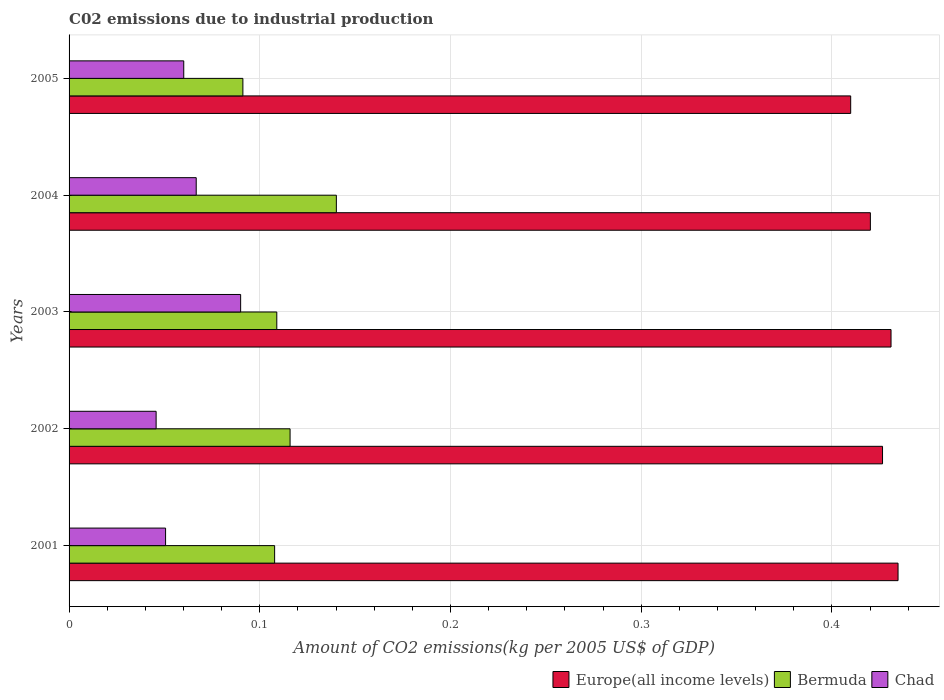How many groups of bars are there?
Your answer should be compact. 5. Are the number of bars per tick equal to the number of legend labels?
Your answer should be compact. Yes. In how many cases, is the number of bars for a given year not equal to the number of legend labels?
Offer a very short reply. 0. What is the amount of CO2 emitted due to industrial production in Chad in 2001?
Your response must be concise. 0.05. Across all years, what is the maximum amount of CO2 emitted due to industrial production in Bermuda?
Your answer should be compact. 0.14. Across all years, what is the minimum amount of CO2 emitted due to industrial production in Chad?
Your answer should be compact. 0.05. In which year was the amount of CO2 emitted due to industrial production in Bermuda maximum?
Keep it short and to the point. 2004. What is the total amount of CO2 emitted due to industrial production in Bermuda in the graph?
Provide a succinct answer. 0.56. What is the difference between the amount of CO2 emitted due to industrial production in Chad in 2001 and that in 2002?
Your answer should be compact. 0. What is the difference between the amount of CO2 emitted due to industrial production in Europe(all income levels) in 2001 and the amount of CO2 emitted due to industrial production in Chad in 2003?
Your answer should be very brief. 0.34. What is the average amount of CO2 emitted due to industrial production in Bermuda per year?
Provide a succinct answer. 0.11. In the year 2003, what is the difference between the amount of CO2 emitted due to industrial production in Chad and amount of CO2 emitted due to industrial production in Bermuda?
Provide a succinct answer. -0.02. What is the ratio of the amount of CO2 emitted due to industrial production in Chad in 2001 to that in 2003?
Offer a terse response. 0.56. Is the amount of CO2 emitted due to industrial production in Chad in 2004 less than that in 2005?
Offer a very short reply. No. Is the difference between the amount of CO2 emitted due to industrial production in Chad in 2004 and 2005 greater than the difference between the amount of CO2 emitted due to industrial production in Bermuda in 2004 and 2005?
Offer a very short reply. No. What is the difference between the highest and the second highest amount of CO2 emitted due to industrial production in Europe(all income levels)?
Keep it short and to the point. 0. What is the difference between the highest and the lowest amount of CO2 emitted due to industrial production in Bermuda?
Offer a terse response. 0.05. In how many years, is the amount of CO2 emitted due to industrial production in Europe(all income levels) greater than the average amount of CO2 emitted due to industrial production in Europe(all income levels) taken over all years?
Your answer should be very brief. 3. What does the 3rd bar from the top in 2003 represents?
Your answer should be compact. Europe(all income levels). What does the 2nd bar from the bottom in 2003 represents?
Offer a terse response. Bermuda. Are all the bars in the graph horizontal?
Your response must be concise. Yes. How many years are there in the graph?
Your answer should be compact. 5. What is the difference between two consecutive major ticks on the X-axis?
Keep it short and to the point. 0.1. Does the graph contain grids?
Provide a succinct answer. Yes. How many legend labels are there?
Your response must be concise. 3. How are the legend labels stacked?
Ensure brevity in your answer.  Horizontal. What is the title of the graph?
Offer a terse response. C02 emissions due to industrial production. Does "Seychelles" appear as one of the legend labels in the graph?
Provide a short and direct response. No. What is the label or title of the X-axis?
Provide a succinct answer. Amount of CO2 emissions(kg per 2005 US$ of GDP). What is the label or title of the Y-axis?
Keep it short and to the point. Years. What is the Amount of CO2 emissions(kg per 2005 US$ of GDP) in Europe(all income levels) in 2001?
Your answer should be compact. 0.43. What is the Amount of CO2 emissions(kg per 2005 US$ of GDP) in Bermuda in 2001?
Your response must be concise. 0.11. What is the Amount of CO2 emissions(kg per 2005 US$ of GDP) of Chad in 2001?
Your answer should be very brief. 0.05. What is the Amount of CO2 emissions(kg per 2005 US$ of GDP) of Europe(all income levels) in 2002?
Offer a very short reply. 0.43. What is the Amount of CO2 emissions(kg per 2005 US$ of GDP) in Bermuda in 2002?
Provide a short and direct response. 0.12. What is the Amount of CO2 emissions(kg per 2005 US$ of GDP) of Chad in 2002?
Your answer should be compact. 0.05. What is the Amount of CO2 emissions(kg per 2005 US$ of GDP) of Europe(all income levels) in 2003?
Ensure brevity in your answer.  0.43. What is the Amount of CO2 emissions(kg per 2005 US$ of GDP) of Bermuda in 2003?
Provide a short and direct response. 0.11. What is the Amount of CO2 emissions(kg per 2005 US$ of GDP) of Chad in 2003?
Offer a terse response. 0.09. What is the Amount of CO2 emissions(kg per 2005 US$ of GDP) of Europe(all income levels) in 2004?
Give a very brief answer. 0.42. What is the Amount of CO2 emissions(kg per 2005 US$ of GDP) in Bermuda in 2004?
Your response must be concise. 0.14. What is the Amount of CO2 emissions(kg per 2005 US$ of GDP) of Chad in 2004?
Give a very brief answer. 0.07. What is the Amount of CO2 emissions(kg per 2005 US$ of GDP) in Europe(all income levels) in 2005?
Provide a short and direct response. 0.41. What is the Amount of CO2 emissions(kg per 2005 US$ of GDP) in Bermuda in 2005?
Your answer should be compact. 0.09. What is the Amount of CO2 emissions(kg per 2005 US$ of GDP) in Chad in 2005?
Provide a short and direct response. 0.06. Across all years, what is the maximum Amount of CO2 emissions(kg per 2005 US$ of GDP) of Europe(all income levels)?
Offer a very short reply. 0.43. Across all years, what is the maximum Amount of CO2 emissions(kg per 2005 US$ of GDP) of Bermuda?
Your response must be concise. 0.14. Across all years, what is the maximum Amount of CO2 emissions(kg per 2005 US$ of GDP) of Chad?
Keep it short and to the point. 0.09. Across all years, what is the minimum Amount of CO2 emissions(kg per 2005 US$ of GDP) of Europe(all income levels)?
Provide a succinct answer. 0.41. Across all years, what is the minimum Amount of CO2 emissions(kg per 2005 US$ of GDP) of Bermuda?
Give a very brief answer. 0.09. Across all years, what is the minimum Amount of CO2 emissions(kg per 2005 US$ of GDP) of Chad?
Ensure brevity in your answer.  0.05. What is the total Amount of CO2 emissions(kg per 2005 US$ of GDP) in Europe(all income levels) in the graph?
Provide a succinct answer. 2.12. What is the total Amount of CO2 emissions(kg per 2005 US$ of GDP) in Bermuda in the graph?
Ensure brevity in your answer.  0.56. What is the total Amount of CO2 emissions(kg per 2005 US$ of GDP) of Chad in the graph?
Give a very brief answer. 0.31. What is the difference between the Amount of CO2 emissions(kg per 2005 US$ of GDP) of Europe(all income levels) in 2001 and that in 2002?
Provide a succinct answer. 0.01. What is the difference between the Amount of CO2 emissions(kg per 2005 US$ of GDP) in Bermuda in 2001 and that in 2002?
Offer a very short reply. -0.01. What is the difference between the Amount of CO2 emissions(kg per 2005 US$ of GDP) in Chad in 2001 and that in 2002?
Your answer should be very brief. 0.01. What is the difference between the Amount of CO2 emissions(kg per 2005 US$ of GDP) in Europe(all income levels) in 2001 and that in 2003?
Give a very brief answer. 0. What is the difference between the Amount of CO2 emissions(kg per 2005 US$ of GDP) in Bermuda in 2001 and that in 2003?
Give a very brief answer. -0. What is the difference between the Amount of CO2 emissions(kg per 2005 US$ of GDP) of Chad in 2001 and that in 2003?
Offer a terse response. -0.04. What is the difference between the Amount of CO2 emissions(kg per 2005 US$ of GDP) of Europe(all income levels) in 2001 and that in 2004?
Offer a terse response. 0.01. What is the difference between the Amount of CO2 emissions(kg per 2005 US$ of GDP) in Bermuda in 2001 and that in 2004?
Your answer should be very brief. -0.03. What is the difference between the Amount of CO2 emissions(kg per 2005 US$ of GDP) of Chad in 2001 and that in 2004?
Your answer should be compact. -0.02. What is the difference between the Amount of CO2 emissions(kg per 2005 US$ of GDP) in Europe(all income levels) in 2001 and that in 2005?
Offer a terse response. 0.02. What is the difference between the Amount of CO2 emissions(kg per 2005 US$ of GDP) of Bermuda in 2001 and that in 2005?
Your answer should be compact. 0.02. What is the difference between the Amount of CO2 emissions(kg per 2005 US$ of GDP) of Chad in 2001 and that in 2005?
Your answer should be very brief. -0.01. What is the difference between the Amount of CO2 emissions(kg per 2005 US$ of GDP) in Europe(all income levels) in 2002 and that in 2003?
Keep it short and to the point. -0. What is the difference between the Amount of CO2 emissions(kg per 2005 US$ of GDP) of Bermuda in 2002 and that in 2003?
Provide a succinct answer. 0.01. What is the difference between the Amount of CO2 emissions(kg per 2005 US$ of GDP) of Chad in 2002 and that in 2003?
Your answer should be very brief. -0.04. What is the difference between the Amount of CO2 emissions(kg per 2005 US$ of GDP) of Europe(all income levels) in 2002 and that in 2004?
Offer a very short reply. 0.01. What is the difference between the Amount of CO2 emissions(kg per 2005 US$ of GDP) in Bermuda in 2002 and that in 2004?
Provide a short and direct response. -0.02. What is the difference between the Amount of CO2 emissions(kg per 2005 US$ of GDP) in Chad in 2002 and that in 2004?
Offer a terse response. -0.02. What is the difference between the Amount of CO2 emissions(kg per 2005 US$ of GDP) of Europe(all income levels) in 2002 and that in 2005?
Your answer should be compact. 0.02. What is the difference between the Amount of CO2 emissions(kg per 2005 US$ of GDP) of Bermuda in 2002 and that in 2005?
Keep it short and to the point. 0.02. What is the difference between the Amount of CO2 emissions(kg per 2005 US$ of GDP) in Chad in 2002 and that in 2005?
Offer a very short reply. -0.01. What is the difference between the Amount of CO2 emissions(kg per 2005 US$ of GDP) of Europe(all income levels) in 2003 and that in 2004?
Make the answer very short. 0.01. What is the difference between the Amount of CO2 emissions(kg per 2005 US$ of GDP) of Bermuda in 2003 and that in 2004?
Ensure brevity in your answer.  -0.03. What is the difference between the Amount of CO2 emissions(kg per 2005 US$ of GDP) of Chad in 2003 and that in 2004?
Keep it short and to the point. 0.02. What is the difference between the Amount of CO2 emissions(kg per 2005 US$ of GDP) of Europe(all income levels) in 2003 and that in 2005?
Make the answer very short. 0.02. What is the difference between the Amount of CO2 emissions(kg per 2005 US$ of GDP) of Bermuda in 2003 and that in 2005?
Your answer should be compact. 0.02. What is the difference between the Amount of CO2 emissions(kg per 2005 US$ of GDP) of Chad in 2003 and that in 2005?
Offer a terse response. 0.03. What is the difference between the Amount of CO2 emissions(kg per 2005 US$ of GDP) of Europe(all income levels) in 2004 and that in 2005?
Offer a terse response. 0.01. What is the difference between the Amount of CO2 emissions(kg per 2005 US$ of GDP) of Bermuda in 2004 and that in 2005?
Keep it short and to the point. 0.05. What is the difference between the Amount of CO2 emissions(kg per 2005 US$ of GDP) of Chad in 2004 and that in 2005?
Provide a short and direct response. 0.01. What is the difference between the Amount of CO2 emissions(kg per 2005 US$ of GDP) of Europe(all income levels) in 2001 and the Amount of CO2 emissions(kg per 2005 US$ of GDP) of Bermuda in 2002?
Your answer should be very brief. 0.32. What is the difference between the Amount of CO2 emissions(kg per 2005 US$ of GDP) in Europe(all income levels) in 2001 and the Amount of CO2 emissions(kg per 2005 US$ of GDP) in Chad in 2002?
Keep it short and to the point. 0.39. What is the difference between the Amount of CO2 emissions(kg per 2005 US$ of GDP) of Bermuda in 2001 and the Amount of CO2 emissions(kg per 2005 US$ of GDP) of Chad in 2002?
Give a very brief answer. 0.06. What is the difference between the Amount of CO2 emissions(kg per 2005 US$ of GDP) in Europe(all income levels) in 2001 and the Amount of CO2 emissions(kg per 2005 US$ of GDP) in Bermuda in 2003?
Keep it short and to the point. 0.33. What is the difference between the Amount of CO2 emissions(kg per 2005 US$ of GDP) of Europe(all income levels) in 2001 and the Amount of CO2 emissions(kg per 2005 US$ of GDP) of Chad in 2003?
Keep it short and to the point. 0.34. What is the difference between the Amount of CO2 emissions(kg per 2005 US$ of GDP) in Bermuda in 2001 and the Amount of CO2 emissions(kg per 2005 US$ of GDP) in Chad in 2003?
Provide a short and direct response. 0.02. What is the difference between the Amount of CO2 emissions(kg per 2005 US$ of GDP) in Europe(all income levels) in 2001 and the Amount of CO2 emissions(kg per 2005 US$ of GDP) in Bermuda in 2004?
Offer a terse response. 0.29. What is the difference between the Amount of CO2 emissions(kg per 2005 US$ of GDP) of Europe(all income levels) in 2001 and the Amount of CO2 emissions(kg per 2005 US$ of GDP) of Chad in 2004?
Provide a succinct answer. 0.37. What is the difference between the Amount of CO2 emissions(kg per 2005 US$ of GDP) of Bermuda in 2001 and the Amount of CO2 emissions(kg per 2005 US$ of GDP) of Chad in 2004?
Offer a very short reply. 0.04. What is the difference between the Amount of CO2 emissions(kg per 2005 US$ of GDP) in Europe(all income levels) in 2001 and the Amount of CO2 emissions(kg per 2005 US$ of GDP) in Bermuda in 2005?
Give a very brief answer. 0.34. What is the difference between the Amount of CO2 emissions(kg per 2005 US$ of GDP) in Europe(all income levels) in 2001 and the Amount of CO2 emissions(kg per 2005 US$ of GDP) in Chad in 2005?
Your answer should be compact. 0.37. What is the difference between the Amount of CO2 emissions(kg per 2005 US$ of GDP) of Bermuda in 2001 and the Amount of CO2 emissions(kg per 2005 US$ of GDP) of Chad in 2005?
Your answer should be compact. 0.05. What is the difference between the Amount of CO2 emissions(kg per 2005 US$ of GDP) in Europe(all income levels) in 2002 and the Amount of CO2 emissions(kg per 2005 US$ of GDP) in Bermuda in 2003?
Make the answer very short. 0.32. What is the difference between the Amount of CO2 emissions(kg per 2005 US$ of GDP) in Europe(all income levels) in 2002 and the Amount of CO2 emissions(kg per 2005 US$ of GDP) in Chad in 2003?
Provide a succinct answer. 0.34. What is the difference between the Amount of CO2 emissions(kg per 2005 US$ of GDP) in Bermuda in 2002 and the Amount of CO2 emissions(kg per 2005 US$ of GDP) in Chad in 2003?
Ensure brevity in your answer.  0.03. What is the difference between the Amount of CO2 emissions(kg per 2005 US$ of GDP) of Europe(all income levels) in 2002 and the Amount of CO2 emissions(kg per 2005 US$ of GDP) of Bermuda in 2004?
Ensure brevity in your answer.  0.29. What is the difference between the Amount of CO2 emissions(kg per 2005 US$ of GDP) of Europe(all income levels) in 2002 and the Amount of CO2 emissions(kg per 2005 US$ of GDP) of Chad in 2004?
Your answer should be very brief. 0.36. What is the difference between the Amount of CO2 emissions(kg per 2005 US$ of GDP) of Bermuda in 2002 and the Amount of CO2 emissions(kg per 2005 US$ of GDP) of Chad in 2004?
Your response must be concise. 0.05. What is the difference between the Amount of CO2 emissions(kg per 2005 US$ of GDP) of Europe(all income levels) in 2002 and the Amount of CO2 emissions(kg per 2005 US$ of GDP) of Bermuda in 2005?
Provide a short and direct response. 0.34. What is the difference between the Amount of CO2 emissions(kg per 2005 US$ of GDP) in Europe(all income levels) in 2002 and the Amount of CO2 emissions(kg per 2005 US$ of GDP) in Chad in 2005?
Your answer should be compact. 0.37. What is the difference between the Amount of CO2 emissions(kg per 2005 US$ of GDP) of Bermuda in 2002 and the Amount of CO2 emissions(kg per 2005 US$ of GDP) of Chad in 2005?
Give a very brief answer. 0.06. What is the difference between the Amount of CO2 emissions(kg per 2005 US$ of GDP) of Europe(all income levels) in 2003 and the Amount of CO2 emissions(kg per 2005 US$ of GDP) of Bermuda in 2004?
Provide a succinct answer. 0.29. What is the difference between the Amount of CO2 emissions(kg per 2005 US$ of GDP) of Europe(all income levels) in 2003 and the Amount of CO2 emissions(kg per 2005 US$ of GDP) of Chad in 2004?
Keep it short and to the point. 0.36. What is the difference between the Amount of CO2 emissions(kg per 2005 US$ of GDP) in Bermuda in 2003 and the Amount of CO2 emissions(kg per 2005 US$ of GDP) in Chad in 2004?
Your answer should be very brief. 0.04. What is the difference between the Amount of CO2 emissions(kg per 2005 US$ of GDP) in Europe(all income levels) in 2003 and the Amount of CO2 emissions(kg per 2005 US$ of GDP) in Bermuda in 2005?
Provide a short and direct response. 0.34. What is the difference between the Amount of CO2 emissions(kg per 2005 US$ of GDP) of Europe(all income levels) in 2003 and the Amount of CO2 emissions(kg per 2005 US$ of GDP) of Chad in 2005?
Your response must be concise. 0.37. What is the difference between the Amount of CO2 emissions(kg per 2005 US$ of GDP) of Bermuda in 2003 and the Amount of CO2 emissions(kg per 2005 US$ of GDP) of Chad in 2005?
Keep it short and to the point. 0.05. What is the difference between the Amount of CO2 emissions(kg per 2005 US$ of GDP) in Europe(all income levels) in 2004 and the Amount of CO2 emissions(kg per 2005 US$ of GDP) in Bermuda in 2005?
Keep it short and to the point. 0.33. What is the difference between the Amount of CO2 emissions(kg per 2005 US$ of GDP) of Europe(all income levels) in 2004 and the Amount of CO2 emissions(kg per 2005 US$ of GDP) of Chad in 2005?
Your answer should be very brief. 0.36. What is the difference between the Amount of CO2 emissions(kg per 2005 US$ of GDP) of Bermuda in 2004 and the Amount of CO2 emissions(kg per 2005 US$ of GDP) of Chad in 2005?
Provide a short and direct response. 0.08. What is the average Amount of CO2 emissions(kg per 2005 US$ of GDP) of Europe(all income levels) per year?
Keep it short and to the point. 0.42. What is the average Amount of CO2 emissions(kg per 2005 US$ of GDP) in Bermuda per year?
Provide a short and direct response. 0.11. What is the average Amount of CO2 emissions(kg per 2005 US$ of GDP) in Chad per year?
Your answer should be compact. 0.06. In the year 2001, what is the difference between the Amount of CO2 emissions(kg per 2005 US$ of GDP) of Europe(all income levels) and Amount of CO2 emissions(kg per 2005 US$ of GDP) of Bermuda?
Provide a succinct answer. 0.33. In the year 2001, what is the difference between the Amount of CO2 emissions(kg per 2005 US$ of GDP) in Europe(all income levels) and Amount of CO2 emissions(kg per 2005 US$ of GDP) in Chad?
Your response must be concise. 0.38. In the year 2001, what is the difference between the Amount of CO2 emissions(kg per 2005 US$ of GDP) in Bermuda and Amount of CO2 emissions(kg per 2005 US$ of GDP) in Chad?
Offer a very short reply. 0.06. In the year 2002, what is the difference between the Amount of CO2 emissions(kg per 2005 US$ of GDP) of Europe(all income levels) and Amount of CO2 emissions(kg per 2005 US$ of GDP) of Bermuda?
Your response must be concise. 0.31. In the year 2002, what is the difference between the Amount of CO2 emissions(kg per 2005 US$ of GDP) of Europe(all income levels) and Amount of CO2 emissions(kg per 2005 US$ of GDP) of Chad?
Give a very brief answer. 0.38. In the year 2002, what is the difference between the Amount of CO2 emissions(kg per 2005 US$ of GDP) of Bermuda and Amount of CO2 emissions(kg per 2005 US$ of GDP) of Chad?
Offer a very short reply. 0.07. In the year 2003, what is the difference between the Amount of CO2 emissions(kg per 2005 US$ of GDP) of Europe(all income levels) and Amount of CO2 emissions(kg per 2005 US$ of GDP) of Bermuda?
Ensure brevity in your answer.  0.32. In the year 2003, what is the difference between the Amount of CO2 emissions(kg per 2005 US$ of GDP) in Europe(all income levels) and Amount of CO2 emissions(kg per 2005 US$ of GDP) in Chad?
Your answer should be compact. 0.34. In the year 2003, what is the difference between the Amount of CO2 emissions(kg per 2005 US$ of GDP) in Bermuda and Amount of CO2 emissions(kg per 2005 US$ of GDP) in Chad?
Your answer should be very brief. 0.02. In the year 2004, what is the difference between the Amount of CO2 emissions(kg per 2005 US$ of GDP) of Europe(all income levels) and Amount of CO2 emissions(kg per 2005 US$ of GDP) of Bermuda?
Offer a terse response. 0.28. In the year 2004, what is the difference between the Amount of CO2 emissions(kg per 2005 US$ of GDP) in Europe(all income levels) and Amount of CO2 emissions(kg per 2005 US$ of GDP) in Chad?
Your answer should be very brief. 0.35. In the year 2004, what is the difference between the Amount of CO2 emissions(kg per 2005 US$ of GDP) of Bermuda and Amount of CO2 emissions(kg per 2005 US$ of GDP) of Chad?
Your answer should be compact. 0.07. In the year 2005, what is the difference between the Amount of CO2 emissions(kg per 2005 US$ of GDP) of Europe(all income levels) and Amount of CO2 emissions(kg per 2005 US$ of GDP) of Bermuda?
Offer a very short reply. 0.32. In the year 2005, what is the difference between the Amount of CO2 emissions(kg per 2005 US$ of GDP) of Europe(all income levels) and Amount of CO2 emissions(kg per 2005 US$ of GDP) of Chad?
Ensure brevity in your answer.  0.35. In the year 2005, what is the difference between the Amount of CO2 emissions(kg per 2005 US$ of GDP) of Bermuda and Amount of CO2 emissions(kg per 2005 US$ of GDP) of Chad?
Provide a succinct answer. 0.03. What is the ratio of the Amount of CO2 emissions(kg per 2005 US$ of GDP) in Europe(all income levels) in 2001 to that in 2002?
Your answer should be very brief. 1.02. What is the ratio of the Amount of CO2 emissions(kg per 2005 US$ of GDP) in Bermuda in 2001 to that in 2002?
Ensure brevity in your answer.  0.93. What is the ratio of the Amount of CO2 emissions(kg per 2005 US$ of GDP) in Chad in 2001 to that in 2002?
Make the answer very short. 1.11. What is the ratio of the Amount of CO2 emissions(kg per 2005 US$ of GDP) in Europe(all income levels) in 2001 to that in 2003?
Your answer should be very brief. 1.01. What is the ratio of the Amount of CO2 emissions(kg per 2005 US$ of GDP) of Chad in 2001 to that in 2003?
Your response must be concise. 0.56. What is the ratio of the Amount of CO2 emissions(kg per 2005 US$ of GDP) of Europe(all income levels) in 2001 to that in 2004?
Your answer should be compact. 1.03. What is the ratio of the Amount of CO2 emissions(kg per 2005 US$ of GDP) of Bermuda in 2001 to that in 2004?
Provide a short and direct response. 0.77. What is the ratio of the Amount of CO2 emissions(kg per 2005 US$ of GDP) of Chad in 2001 to that in 2004?
Offer a very short reply. 0.76. What is the ratio of the Amount of CO2 emissions(kg per 2005 US$ of GDP) of Europe(all income levels) in 2001 to that in 2005?
Offer a terse response. 1.06. What is the ratio of the Amount of CO2 emissions(kg per 2005 US$ of GDP) of Bermuda in 2001 to that in 2005?
Your response must be concise. 1.18. What is the ratio of the Amount of CO2 emissions(kg per 2005 US$ of GDP) in Chad in 2001 to that in 2005?
Provide a short and direct response. 0.84. What is the ratio of the Amount of CO2 emissions(kg per 2005 US$ of GDP) in Bermuda in 2002 to that in 2003?
Offer a terse response. 1.06. What is the ratio of the Amount of CO2 emissions(kg per 2005 US$ of GDP) in Chad in 2002 to that in 2003?
Ensure brevity in your answer.  0.51. What is the ratio of the Amount of CO2 emissions(kg per 2005 US$ of GDP) in Europe(all income levels) in 2002 to that in 2004?
Offer a terse response. 1.02. What is the ratio of the Amount of CO2 emissions(kg per 2005 US$ of GDP) of Bermuda in 2002 to that in 2004?
Offer a terse response. 0.83. What is the ratio of the Amount of CO2 emissions(kg per 2005 US$ of GDP) in Chad in 2002 to that in 2004?
Provide a succinct answer. 0.68. What is the ratio of the Amount of CO2 emissions(kg per 2005 US$ of GDP) of Europe(all income levels) in 2002 to that in 2005?
Give a very brief answer. 1.04. What is the ratio of the Amount of CO2 emissions(kg per 2005 US$ of GDP) of Bermuda in 2002 to that in 2005?
Your response must be concise. 1.27. What is the ratio of the Amount of CO2 emissions(kg per 2005 US$ of GDP) of Chad in 2002 to that in 2005?
Make the answer very short. 0.76. What is the ratio of the Amount of CO2 emissions(kg per 2005 US$ of GDP) in Europe(all income levels) in 2003 to that in 2004?
Give a very brief answer. 1.03. What is the ratio of the Amount of CO2 emissions(kg per 2005 US$ of GDP) of Bermuda in 2003 to that in 2004?
Provide a short and direct response. 0.78. What is the ratio of the Amount of CO2 emissions(kg per 2005 US$ of GDP) in Chad in 2003 to that in 2004?
Give a very brief answer. 1.35. What is the ratio of the Amount of CO2 emissions(kg per 2005 US$ of GDP) in Europe(all income levels) in 2003 to that in 2005?
Give a very brief answer. 1.05. What is the ratio of the Amount of CO2 emissions(kg per 2005 US$ of GDP) of Bermuda in 2003 to that in 2005?
Keep it short and to the point. 1.2. What is the ratio of the Amount of CO2 emissions(kg per 2005 US$ of GDP) of Chad in 2003 to that in 2005?
Provide a succinct answer. 1.5. What is the ratio of the Amount of CO2 emissions(kg per 2005 US$ of GDP) in Europe(all income levels) in 2004 to that in 2005?
Your response must be concise. 1.03. What is the ratio of the Amount of CO2 emissions(kg per 2005 US$ of GDP) in Bermuda in 2004 to that in 2005?
Offer a very short reply. 1.54. What is the ratio of the Amount of CO2 emissions(kg per 2005 US$ of GDP) in Chad in 2004 to that in 2005?
Ensure brevity in your answer.  1.11. What is the difference between the highest and the second highest Amount of CO2 emissions(kg per 2005 US$ of GDP) in Europe(all income levels)?
Provide a succinct answer. 0. What is the difference between the highest and the second highest Amount of CO2 emissions(kg per 2005 US$ of GDP) of Bermuda?
Make the answer very short. 0.02. What is the difference between the highest and the second highest Amount of CO2 emissions(kg per 2005 US$ of GDP) of Chad?
Offer a very short reply. 0.02. What is the difference between the highest and the lowest Amount of CO2 emissions(kg per 2005 US$ of GDP) in Europe(all income levels)?
Provide a succinct answer. 0.02. What is the difference between the highest and the lowest Amount of CO2 emissions(kg per 2005 US$ of GDP) of Bermuda?
Your answer should be compact. 0.05. What is the difference between the highest and the lowest Amount of CO2 emissions(kg per 2005 US$ of GDP) in Chad?
Offer a terse response. 0.04. 